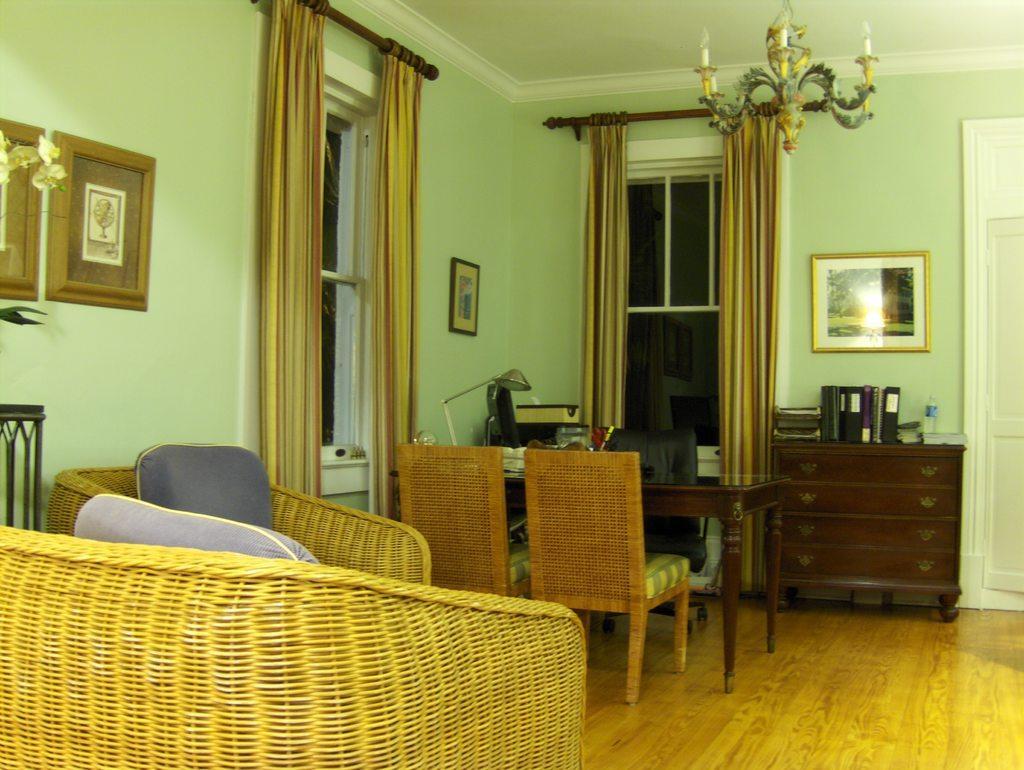How would you summarize this image in a sentence or two? This picture is clicked inside the room and in this room, there are sofa, chair, dining table and cupboards. On table, we see lamp and books. On the right corner of the picture, we see a white door. Beside the door, we see a green wall on which a photo frame is placed. Beside that, we see a window and the curtains. 